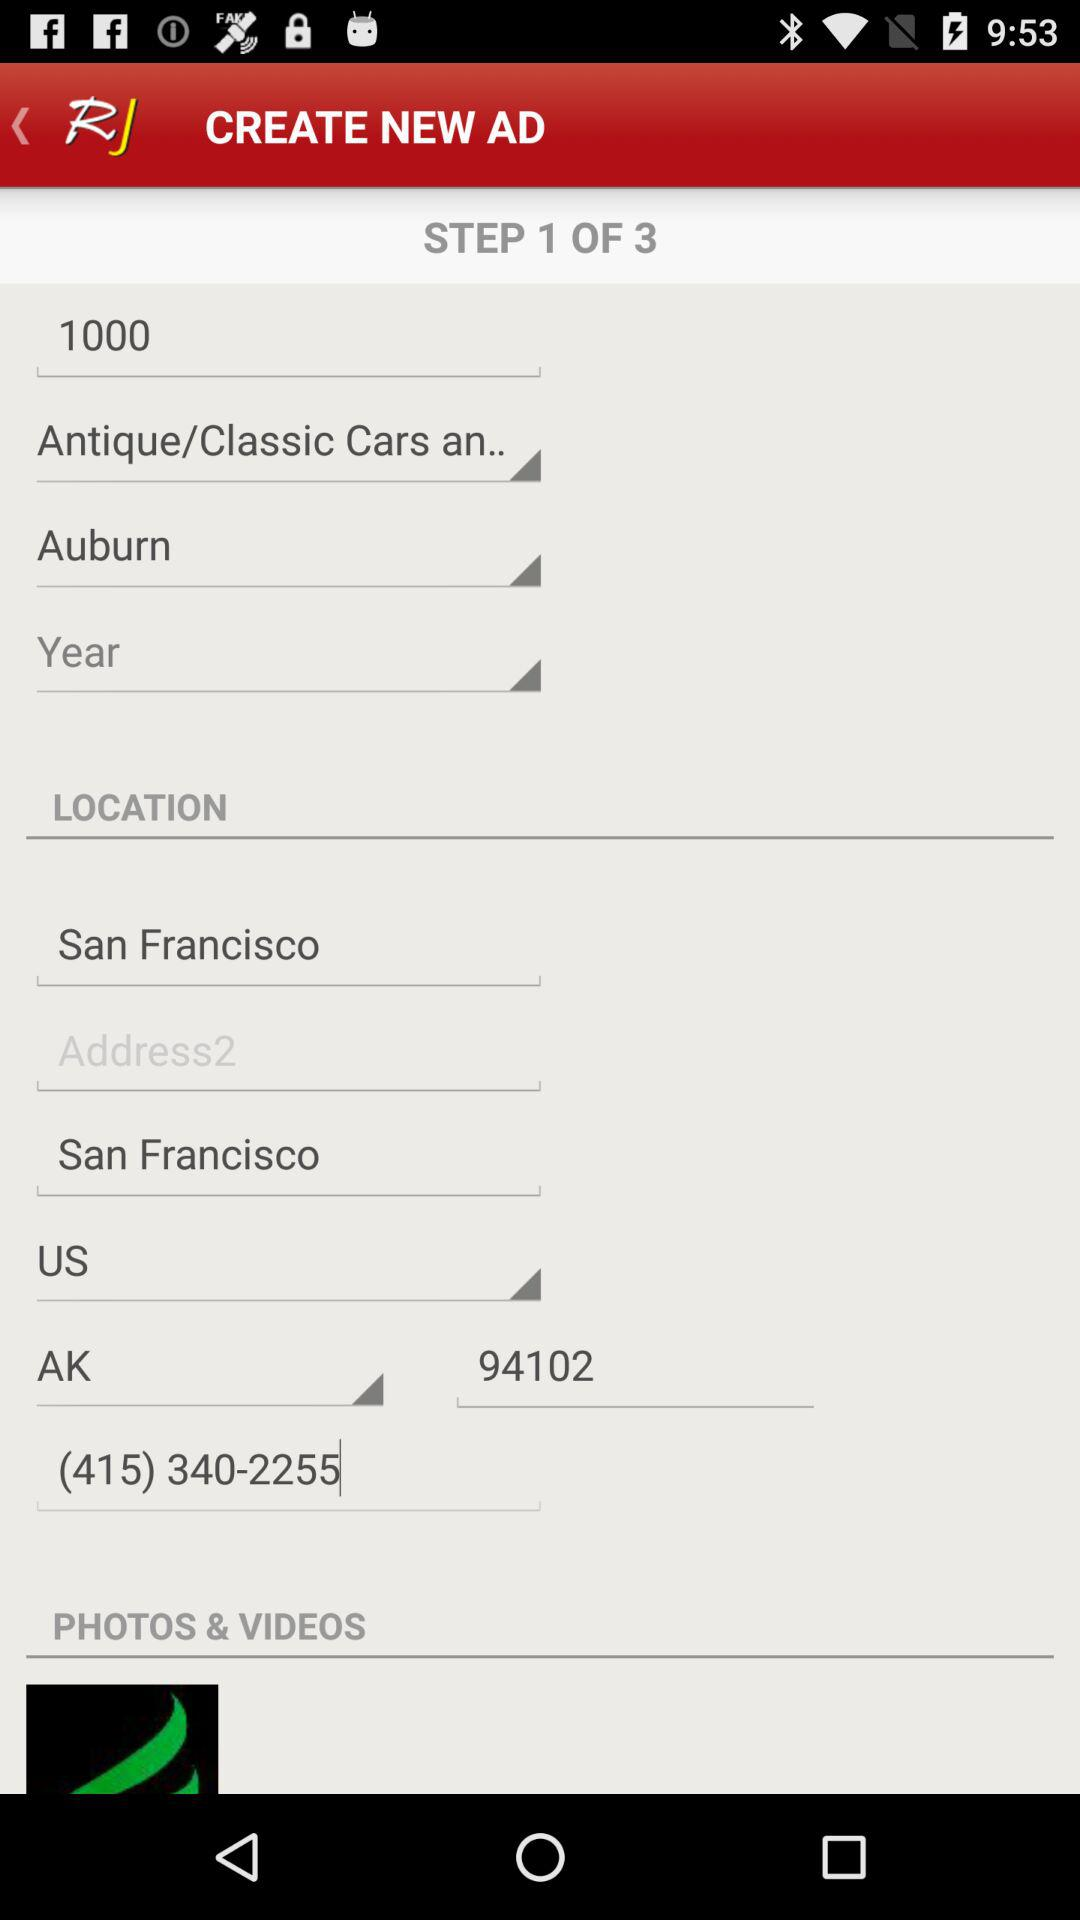At what step of the advertising process is the person? The person is at step 1. 